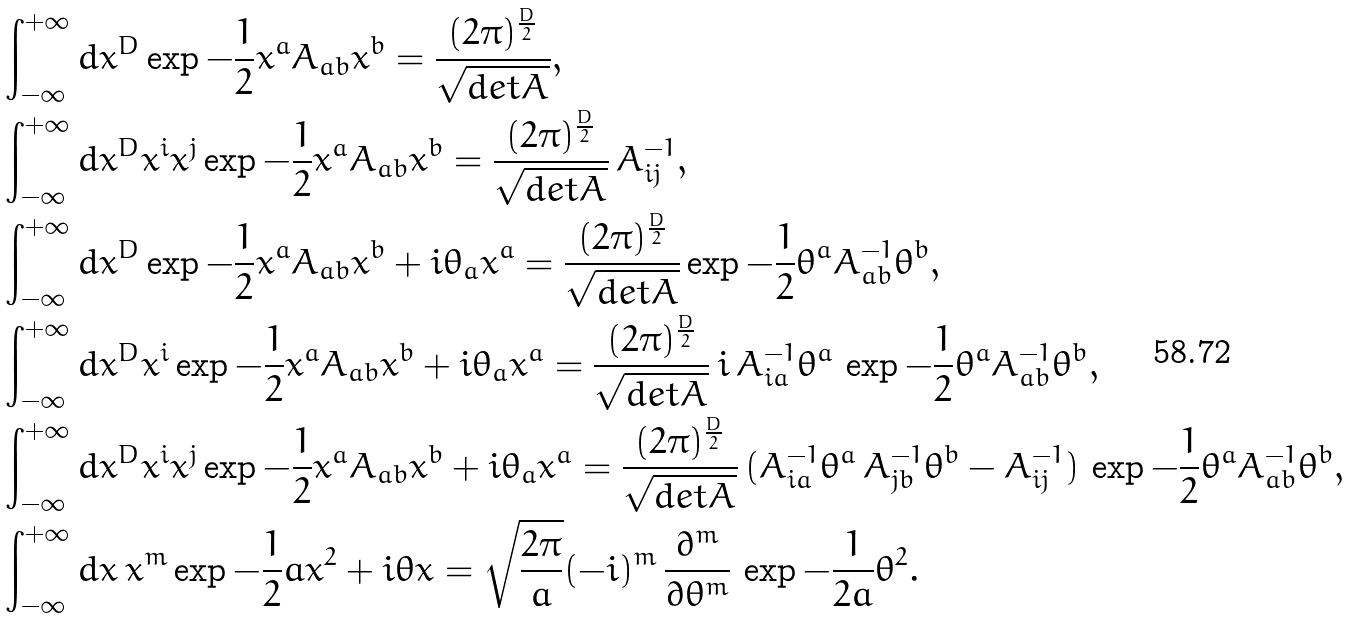Convert formula to latex. <formula><loc_0><loc_0><loc_500><loc_500>& \int _ { - \infty } ^ { + \infty } d x ^ { D } \exp { - \frac { 1 } { 2 } x ^ { a } A _ { a b } x ^ { b } } = \frac { ( 2 \pi ) ^ { \frac { D } { 2 } } } { \sqrt { d e t A } } , \\ & \int _ { - \infty } ^ { + \infty } d x ^ { D } x ^ { i } x ^ { j } \exp { - \frac { 1 } { 2 } x ^ { a } A _ { a b } x ^ { b } } = \frac { ( 2 \pi ) ^ { \frac { D } { 2 } } } { \sqrt { d e t A } } \, A ^ { - 1 } _ { i j } , \\ & \int _ { - \infty } ^ { + \infty } d x ^ { D } \exp { - \frac { 1 } { 2 } x ^ { a } A _ { a b } x ^ { b } } + i \theta _ { a } x ^ { a } = \frac { ( 2 \pi ) ^ { \frac { D } { 2 } } } { \sqrt { d e t A } } \exp { - \frac { 1 } { 2 } \theta ^ { a } A ^ { - 1 } _ { a b } \theta ^ { b } } , \\ & \int _ { - \infty } ^ { + \infty } d x ^ { D } x ^ { i } \exp { - \frac { 1 } { 2 } x ^ { a } A _ { a b } x ^ { b } } + i \theta _ { a } x ^ { a } = \frac { ( 2 \pi ) ^ { \frac { D } { 2 } } } { \sqrt { d e t A } } \, i \, A ^ { - 1 } _ { i a } \theta ^ { a } \, \exp { - \frac { 1 } { 2 } \theta ^ { a } A ^ { - 1 } _ { a b } \theta ^ { b } } , \\ & \int _ { - \infty } ^ { + \infty } d x ^ { D } x ^ { i } x ^ { j } \exp { - \frac { 1 } { 2 } x ^ { a } A _ { a b } x ^ { b } } + i \theta _ { a } x ^ { a } = \frac { ( 2 \pi ) ^ { \frac { D } { 2 } } } { \sqrt { d e t A } } \, ( A ^ { - 1 } _ { i a } \theta ^ { a } \, A ^ { - 1 } _ { j b } \theta ^ { b } - A ^ { - 1 } _ { i j } ) \, \exp { - \frac { 1 } { 2 } \theta ^ { a } A ^ { - 1 } _ { a b } \theta ^ { b } } , \\ & \int _ { - \infty } ^ { + \infty } d x \, x ^ { m } \exp { - \frac { 1 } { 2 } a x ^ { 2 } } + i \theta x = \sqrt { \frac { 2 \pi } { a } } ( - i ) ^ { m } \, \frac { \partial ^ { m } } { \partial \theta ^ { m } } \, \exp { - \frac { 1 } { 2 a } \theta ^ { 2 } } .</formula> 